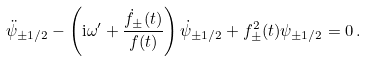<formula> <loc_0><loc_0><loc_500><loc_500>\ddot { \psi } _ { \pm 1 / 2 } - \left ( \mathrm i \omega ^ { \prime } + \frac { \dot { f } _ { \pm } ( t ) } { f ( t ) } \right ) \dot { \psi } _ { \pm 1 / 2 } + f ^ { 2 } _ { \pm } ( t ) \psi _ { \pm 1 / 2 } = 0 \, .</formula> 